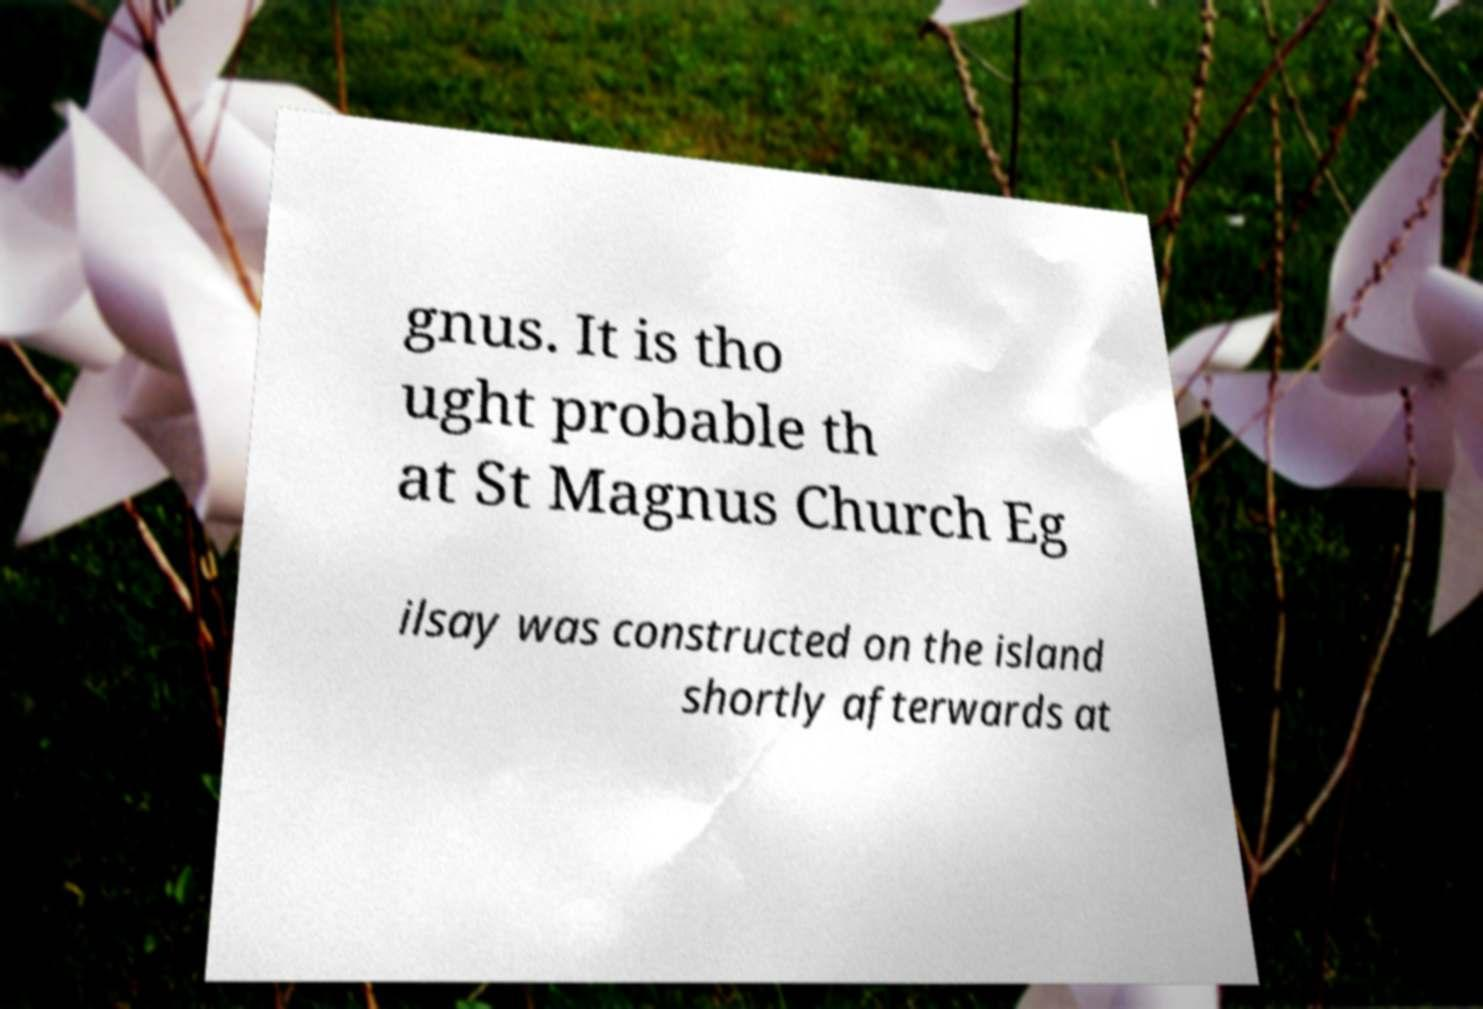For documentation purposes, I need the text within this image transcribed. Could you provide that? gnus. It is tho ught probable th at St Magnus Church Eg ilsay was constructed on the island shortly afterwards at 